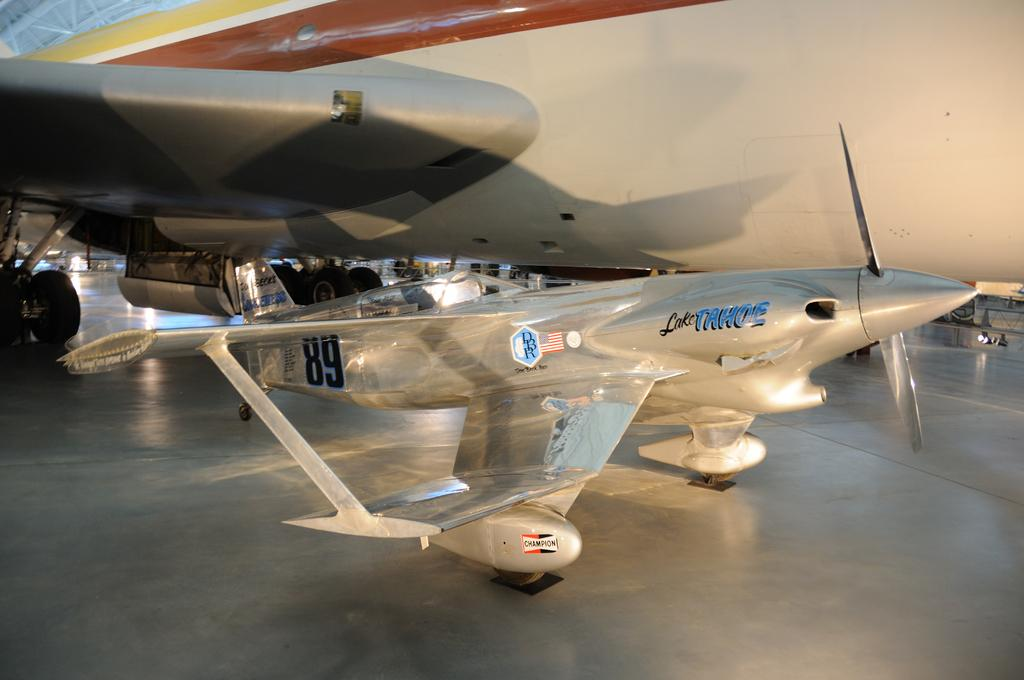What is the main subject of the image? The main subject of the image is an airplane. Can you describe another object in the image? There is an aircraft on the floor in the image. What type of stove is used by the slave in the image? There is no stove or slave present in the image. 